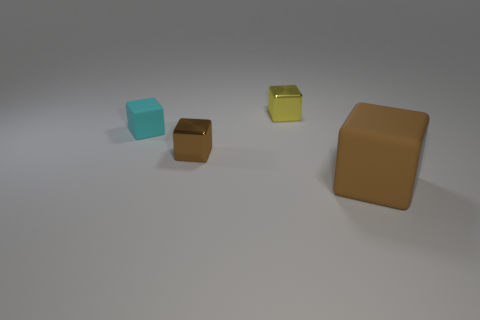Subtract all big blocks. How many blocks are left? 3 Add 3 small blue metal cylinders. How many objects exist? 7 Subtract all cyan blocks. How many blocks are left? 3 Add 1 brown objects. How many brown objects are left? 3 Add 2 red cylinders. How many red cylinders exist? 2 Subtract 0 green balls. How many objects are left? 4 Subtract 2 cubes. How many cubes are left? 2 Subtract all gray cubes. Subtract all gray spheres. How many cubes are left? 4 Subtract all cyan cylinders. How many brown blocks are left? 2 Subtract all large brown rubber objects. Subtract all blue blocks. How many objects are left? 3 